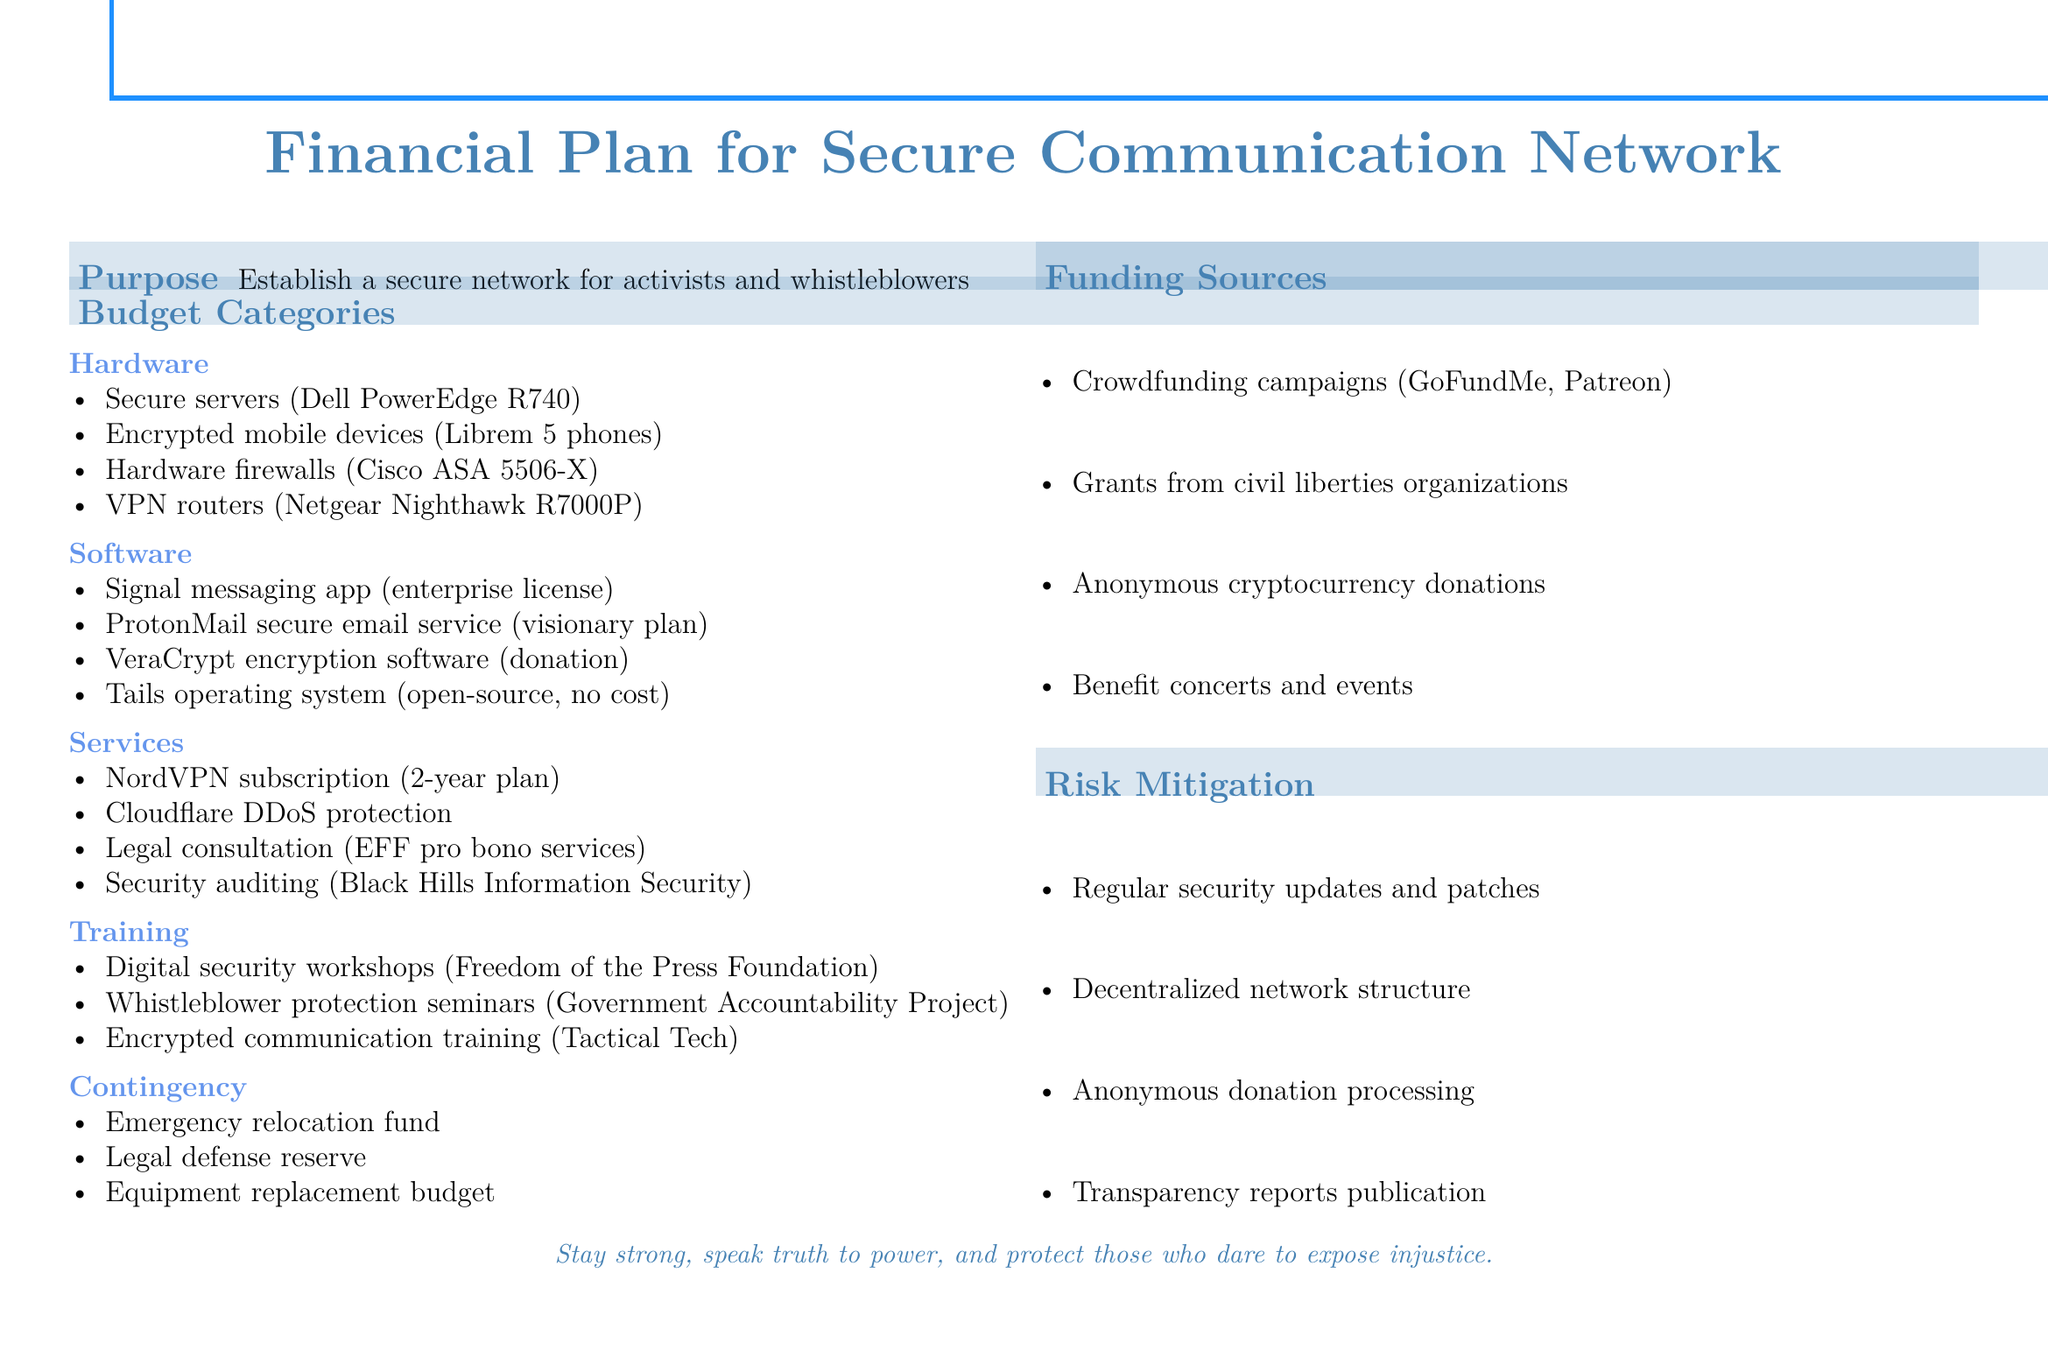What is the primary purpose of the financial plan? The purpose section states that the plan is to establish a secure network for activists and whistleblowers.
Answer: Establish a secure network for activists and whistleblowers What type of hardware is mentioned for this project? The hardware section lists specific equipment required for the network.
Answer: Secure servers, encrypted mobile devices, hardware firewalls, VPN routers What are the funding sources listed? The funding sources section provides a list of ways to acquire the necessary funds.
Answer: Crowdfunding campaigns, grants, anonymous cryptocurrency donations, benefit concerts and events Which software has an enterprise license in the budget? The software section mentions specific software along with their licensing details.
Answer: Signal messaging app (enterprise license) What organization is associated with digital security workshops? The training section mentions specific organizations providing training in security topics.
Answer: Freedom of the Press Foundation What is included in the contingency plan? The contingency section lists specific reserves or funds that can be utilized in emergencies.
Answer: Emergency relocation fund, legal defense reserve, equipment replacement budget How long is the NordVPN subscription plan? The services section specifies the duration of the subscription service.
Answer: 2-year plan Name a service that offers security auditing. The services section lists organizations providing critical services for security.
Answer: Black Hills Information Security Which operating system mentioned is open-source and free? The software section outlines various software used for secure communication.
Answer: Tails operating system (open-source, no cost) 